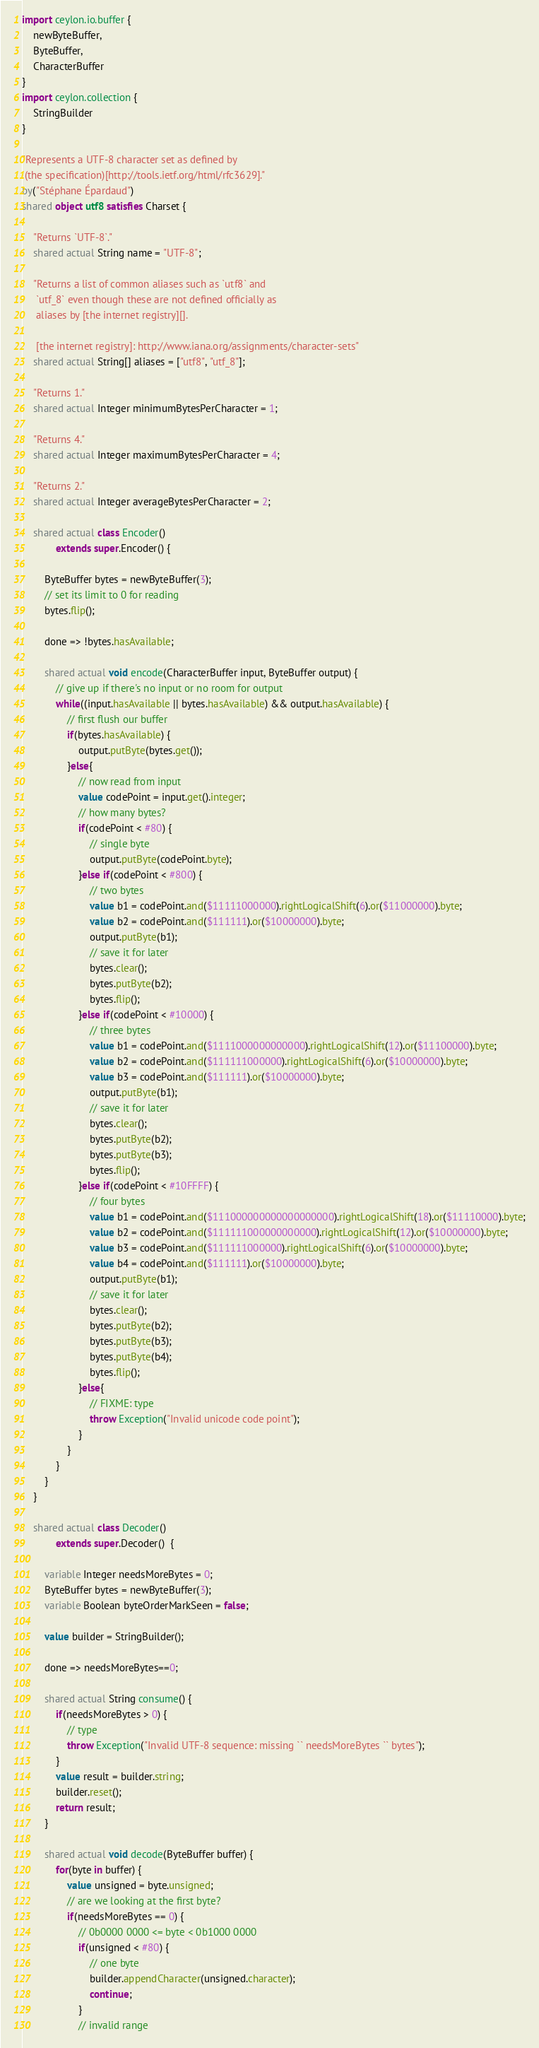<code> <loc_0><loc_0><loc_500><loc_500><_Ceylon_>import ceylon.io.buffer {
    newByteBuffer,
    ByteBuffer,
    CharacterBuffer
}
import ceylon.collection {
    StringBuilder
}

"Represents a UTF-8 character set as defined by
 (the specification)[http://tools.ietf.org/html/rfc3629]."
by("Stéphane Épardaud")
shared object utf8 satisfies Charset {
    
    "Returns `UTF-8`."
    shared actual String name = "UTF-8";
    
    "Returns a list of common aliases such as `utf8` and 
     `utf_8` even though these are not defined officially as 
     aliases by [the internet registry][].
     
     [the internet registry]: http://www.iana.org/assignments/character-sets"
    shared actual String[] aliases = ["utf8", "utf_8"];
    
    "Returns 1."
    shared actual Integer minimumBytesPerCharacter = 1;

    "Returns 4."
    shared actual Integer maximumBytesPerCharacter = 4;

    "Returns 2."
    shared actual Integer averageBytesPerCharacter = 2;

    shared actual class Encoder() 
            extends super.Encoder() {
        
        ByteBuffer bytes = newByteBuffer(3);
        // set its limit to 0 for reading
        bytes.flip();
        
        done => !bytes.hasAvailable;
        
        shared actual void encode(CharacterBuffer input, ByteBuffer output) {
            // give up if there's no input or no room for output
            while((input.hasAvailable || bytes.hasAvailable) && output.hasAvailable) {
                // first flush our buffer
                if(bytes.hasAvailable) {
                    output.putByte(bytes.get());
                }else{
                    // now read from input
                    value codePoint = input.get().integer;
                    // how many bytes?
                    if(codePoint < #80) {
                        // single byte
                        output.putByte(codePoint.byte);
                    }else if(codePoint < #800) {
                        // two bytes
                        value b1 = codePoint.and($11111000000).rightLogicalShift(6).or($11000000).byte;
                        value b2 = codePoint.and($111111).or($10000000).byte;
                        output.putByte(b1);
                        // save it for later
                        bytes.clear();
                        bytes.putByte(b2);
                        bytes.flip();
                    }else if(codePoint < #10000) {
                        // three bytes
                        value b1 = codePoint.and($1111000000000000).rightLogicalShift(12).or($11100000).byte;
                        value b2 = codePoint.and($111111000000).rightLogicalShift(6).or($10000000).byte;
                        value b3 = codePoint.and($111111).or($10000000).byte;
                        output.putByte(b1);
                        // save it for later
                        bytes.clear();
                        bytes.putByte(b2);
                        bytes.putByte(b3);
                        bytes.flip();
                    }else if(codePoint < #10FFFF) {
                        // four bytes
                        value b1 = codePoint.and($111000000000000000000).rightLogicalShift(18).or($11110000).byte;
                        value b2 = codePoint.and($111111000000000000).rightLogicalShift(12).or($10000000).byte;
                        value b3 = codePoint.and($111111000000).rightLogicalShift(6).or($10000000).byte;
                        value b4 = codePoint.and($111111).or($10000000).byte;
                        output.putByte(b1);
                        // save it for later
                        bytes.clear();
                        bytes.putByte(b2);
                        bytes.putByte(b3);
                        bytes.putByte(b4);
                        bytes.flip();
                    }else{
                        // FIXME: type
                        throw Exception("Invalid unicode code point");
                    }
                }
            }
        }
    }
    
    shared actual class Decoder() 
            extends super.Decoder()  {
        
        variable Integer needsMoreBytes = 0;
        ByteBuffer bytes = newByteBuffer(3);
        variable Boolean byteOrderMarkSeen = false;
        
        value builder = StringBuilder();
        
        done => needsMoreBytes==0;
        
        shared actual String consume() {
            if(needsMoreBytes > 0) {
                // type
                throw Exception("Invalid UTF-8 sequence: missing `` needsMoreBytes `` bytes");
            }
            value result = builder.string;
            builder.reset();
            return result;
        }
        
        shared actual void decode(ByteBuffer buffer) {
            for(byte in buffer) {
                value unsigned = byte.unsigned;
                // are we looking at the first byte?
                if(needsMoreBytes == 0) {
                    // 0b0000 0000 <= byte < 0b1000 0000
                    if(unsigned < #80) {
                        // one byte
                        builder.appendCharacter(unsigned.character);
                        continue;
                    }
                    // invalid range</code> 